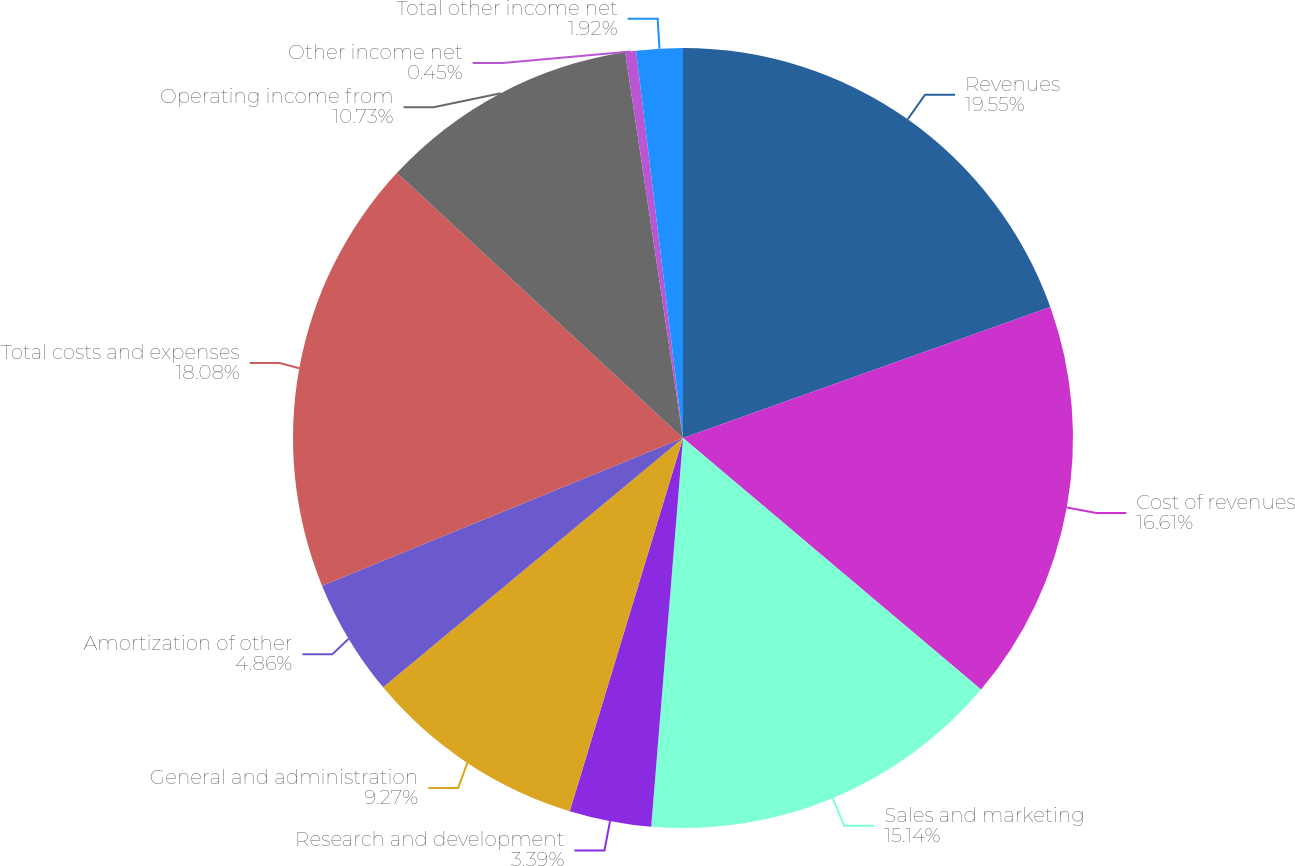Convert chart. <chart><loc_0><loc_0><loc_500><loc_500><pie_chart><fcel>Revenues<fcel>Cost of revenues<fcel>Sales and marketing<fcel>Research and development<fcel>General and administration<fcel>Amortization of other<fcel>Total costs and expenses<fcel>Operating income from<fcel>Other income net<fcel>Total other income net<nl><fcel>19.55%<fcel>16.61%<fcel>15.14%<fcel>3.39%<fcel>9.27%<fcel>4.86%<fcel>18.08%<fcel>10.73%<fcel>0.45%<fcel>1.92%<nl></chart> 